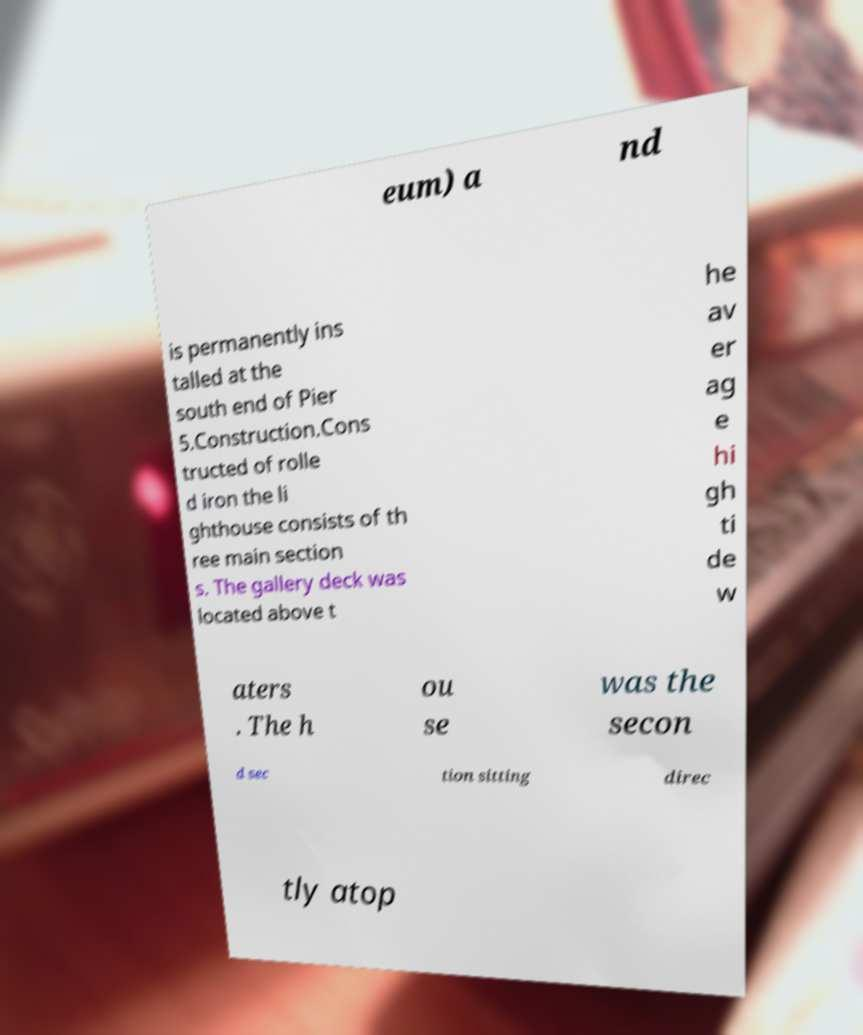Can you accurately transcribe the text from the provided image for me? eum) a nd is permanently ins talled at the south end of Pier 5.Construction.Cons tructed of rolle d iron the li ghthouse consists of th ree main section s. The gallery deck was located above t he av er ag e hi gh ti de w aters . The h ou se was the secon d sec tion sitting direc tly atop 